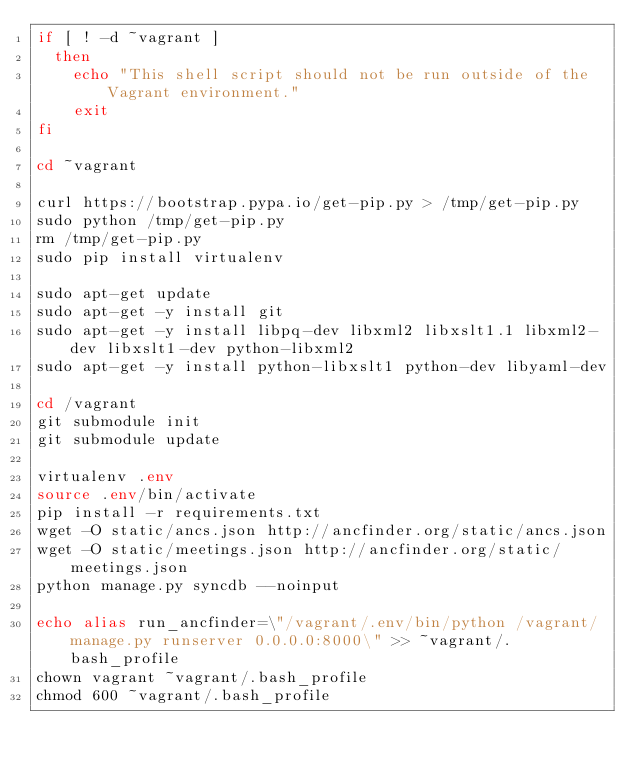<code> <loc_0><loc_0><loc_500><loc_500><_Bash_>if [ ! -d ~vagrant ]
  then
    echo "This shell script should not be run outside of the Vagrant environment."
    exit
fi

cd ~vagrant

curl https://bootstrap.pypa.io/get-pip.py > /tmp/get-pip.py
sudo python /tmp/get-pip.py
rm /tmp/get-pip.py
sudo pip install virtualenv

sudo apt-get update
sudo apt-get -y install git
sudo apt-get -y install libpq-dev libxml2 libxslt1.1 libxml2-dev libxslt1-dev python-libxml2
sudo apt-get -y install python-libxslt1 python-dev libyaml-dev

cd /vagrant
git submodule init
git submodule update

virtualenv .env
source .env/bin/activate
pip install -r requirements.txt
wget -O static/ancs.json http://ancfinder.org/static/ancs.json
wget -O static/meetings.json http://ancfinder.org/static/meetings.json
python manage.py syncdb --noinput

echo alias run_ancfinder=\"/vagrant/.env/bin/python /vagrant/manage.py runserver 0.0.0.0:8000\" >> ~vagrant/.bash_profile
chown vagrant ~vagrant/.bash_profile
chmod 600 ~vagrant/.bash_profile
</code> 